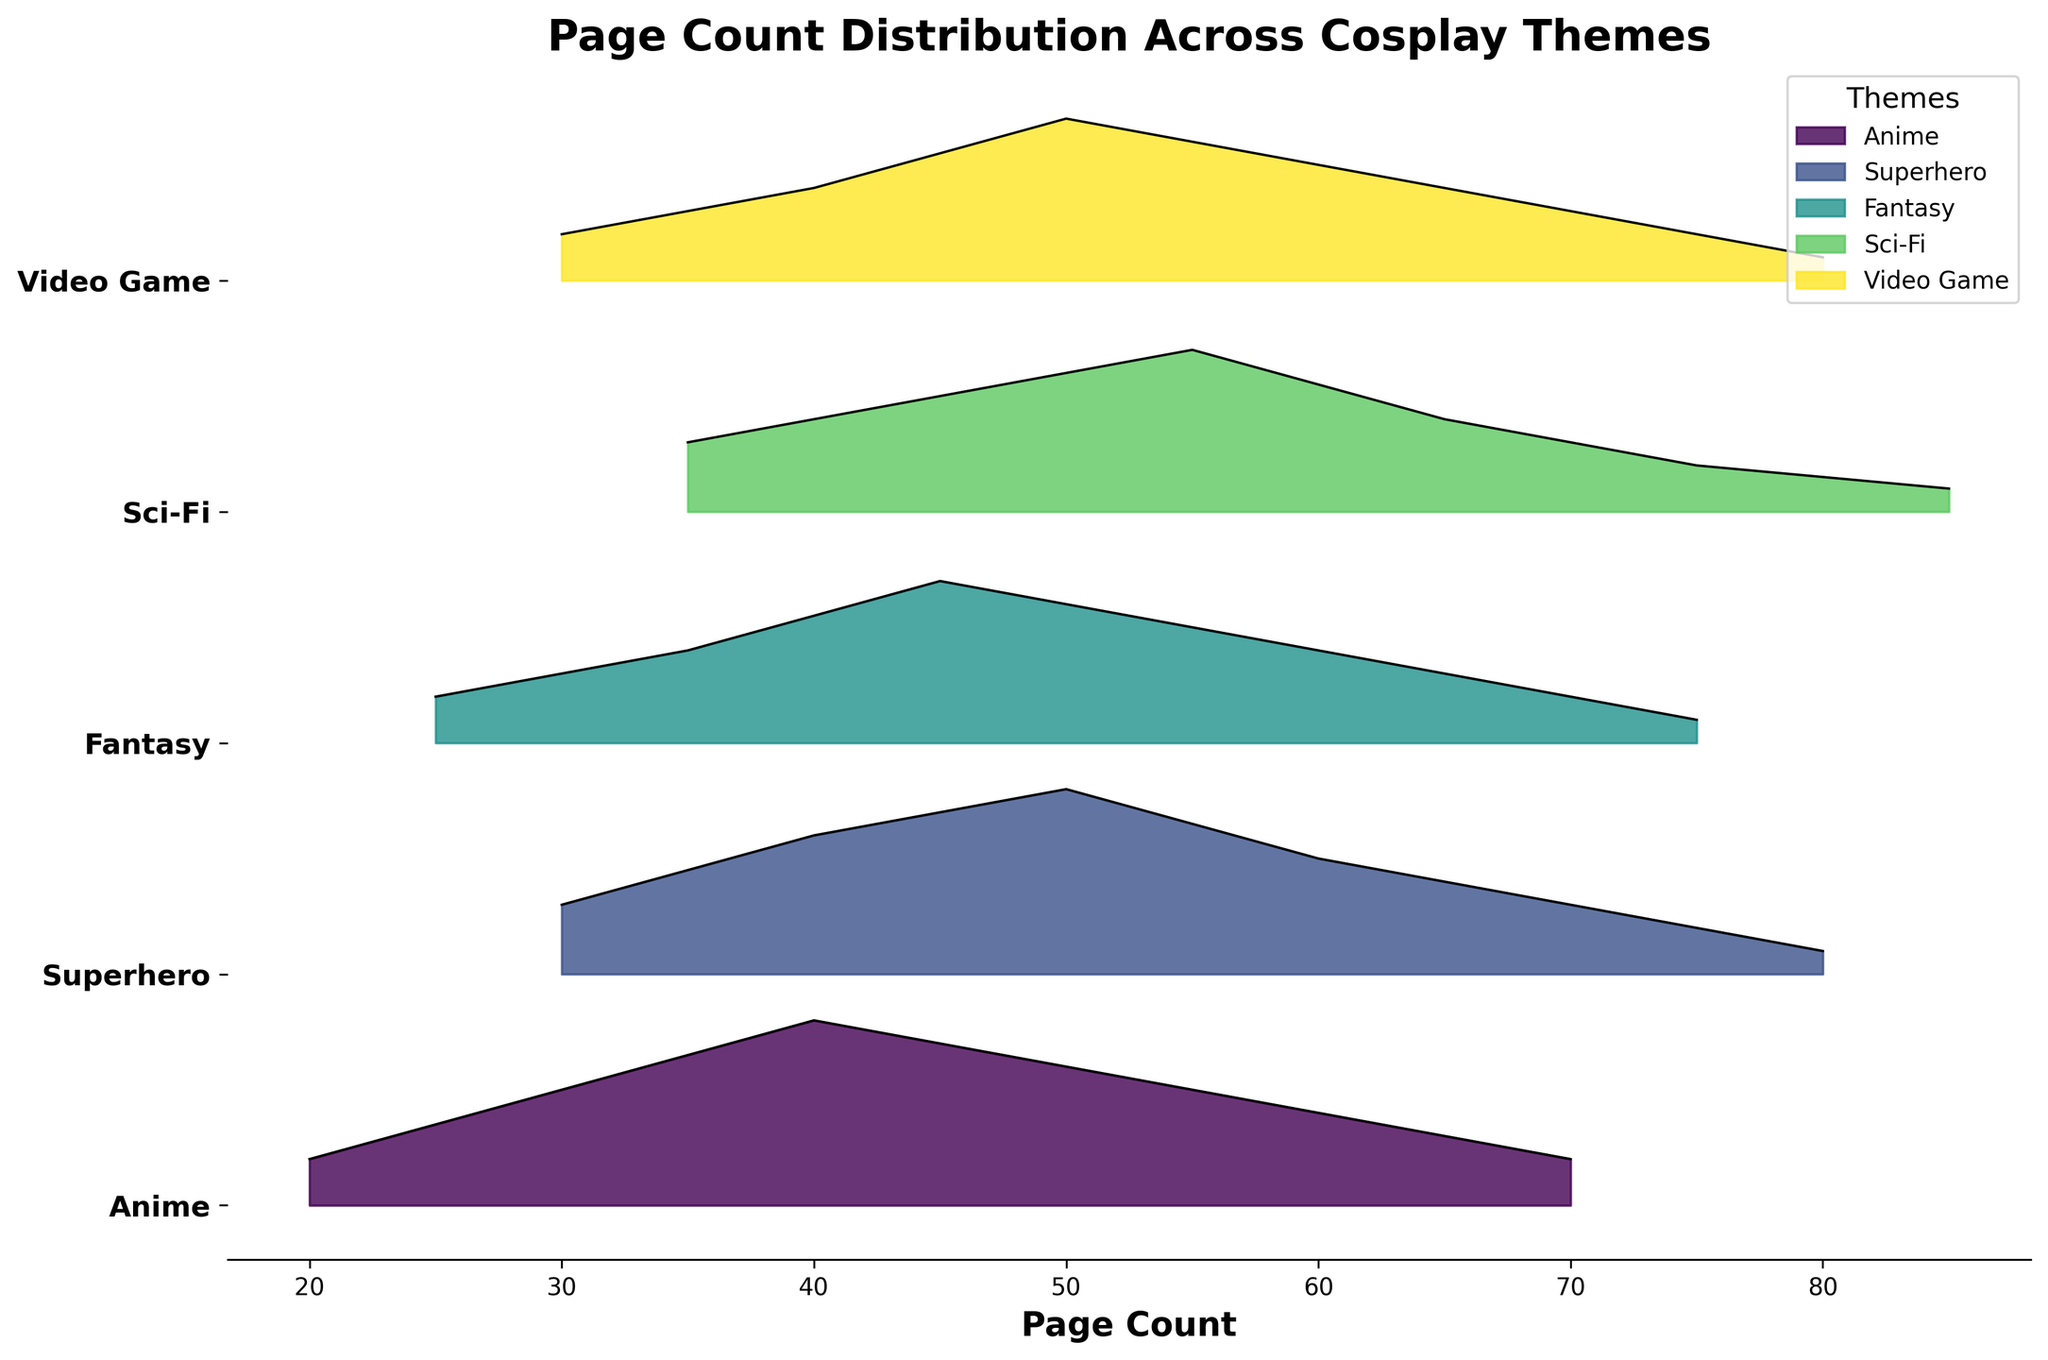Which cosplay theme has the highest peak density? By looking at the highest peak in the density lines, we can observe that the Anime theme’s peak is the highest, reaching a density of 0.08.
Answer: Anime What is the x-axis representing in the plot? The x-axis is labeled 'Page Count', which indicates it represents the number of pages in the photo albums.
Answer: Page Count Which two themes have the lowest peak densities and what are their values? By examining the peaks in the density lines, we can see that Fantasy and Sci-Fi have the lowest peak densities, both reaching a density of 0.07.
Answer: Fantasy and Sci-Fi, 0.07 What is the approximate range of the page count for the Superhero theme? The Superhero theme density curve starts at a page count of 30 and ends at around 80, giving an approximate range of 30–80 pages.
Answer: 30–80 pages How does the peak density of the Sci-Fi theme compare to the Video Game theme? Comparing the peaks in the density curves for both themes, Sci-Fi's peak density is 0.07 while Video Game's peak density is 0.07, indicating they are equal.
Answer: Equal Which theme has the widest distribution of page counts? By comparing the widths of the density curves, the Superhero theme has the widest spread, ranging from approximately 30 to 80 pages.
Answer: Superhero At what page count does the Anime theme reach its maximum density? The peak of the Anime density curve, indicating its highest density, occurs at a page count of 40.
Answer: 40 pages What is the main difference between the peak densities of Fantasy and Superhero themes? The peak density of Fantasy is 0.07, while that of Superhero is 0.08. Therefore, the Superhero theme has a slightly higher peak density by 0.01.
Answer: Superhero is 0.01 higher How many themes have a peak density of 0.07 or higher? The themes with peak densities of 0.07 or higher are Anime, Superhero, Fantasy, and Sci-Fi, totaling 4 themes.
Answer: 4 themes In which section (left or right) of the plot do the higher page counts appear more frequently? By observing that the higher page counts (around 70-85) have density peaks on the right side of the plot for Sci-Fi, Fantasy, and Superhero themes, we conclude the higher page counts appear more frequently on the right.
Answer: Right 